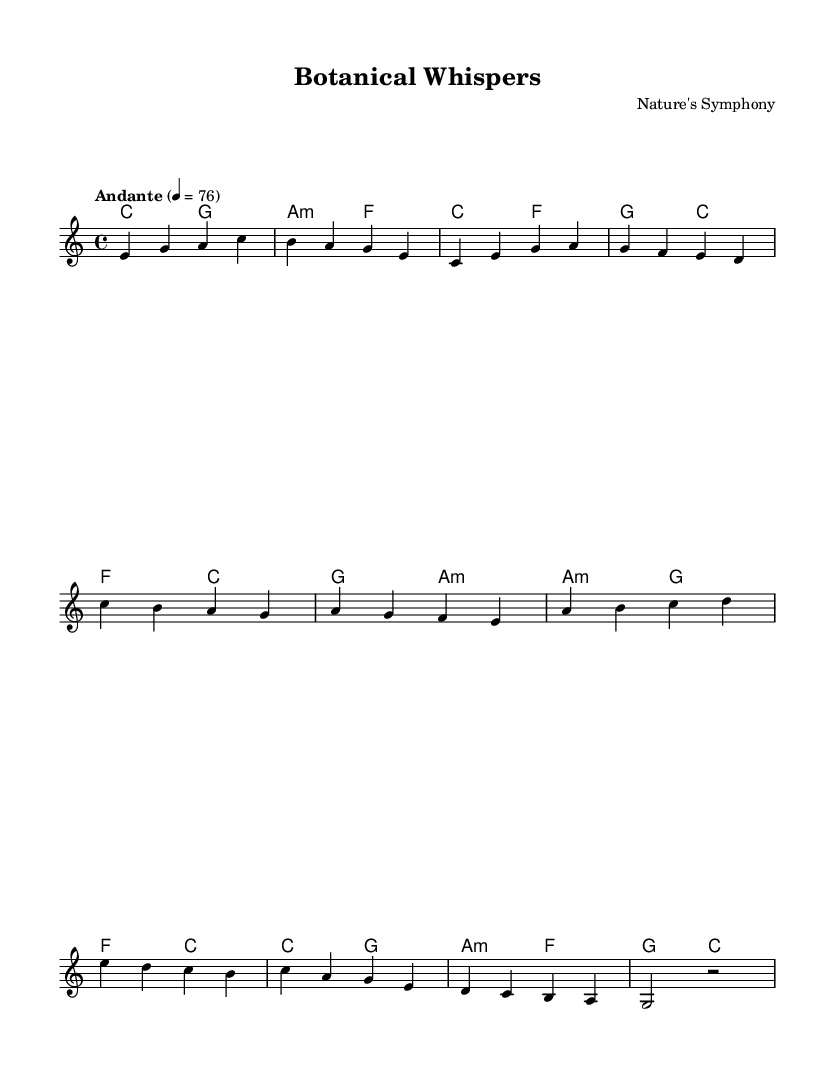What is the key signature of this music? The key signature is C major, which is indicated by the absence of sharps or flats on the staff.
Answer: C major What is the time signature of this music? The time signature is 4/4, as noted in the beginning of the score, indicating four beats per measure with each quarter note getting one beat.
Answer: 4/4 What is the tempo marking of the piece? The tempo marking is "Andante," which suggests a moderately slow tempo, and is marked with a metronome indication of 76 beats per minute.
Answer: Andante How many sections are indicated in this score? The score features distinct sections labeled as Intro, Verse, Chorus, Bridge, and Outro, which can be identified by different musical phrases throughout the piece.
Answer: Five What is the last chord played in the Outro? The last chord in the Outro is a G major chord, evidenced by the chord symbols presented before the musical notes in the score.
Answer: G Which note starts the Bridge section? The Bridge section begins with the note A, as shown at the start of the bridge measures marked in the sheet music.
Answer: A Are there any minor chords in this music? Yes, there is an A minor chord in the specified measures which is indicated by the "m" symbol following the chord letter in the harmony part.
Answer: Yes 